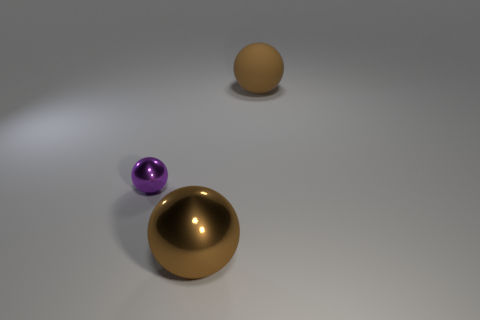Add 2 small brown matte balls. How many objects exist? 5 Add 3 matte things. How many matte things are left? 4 Add 2 tiny purple metallic objects. How many tiny purple metallic objects exist? 3 Subtract 0 purple cubes. How many objects are left? 3 Subtract all small green blocks. Subtract all brown spheres. How many objects are left? 1 